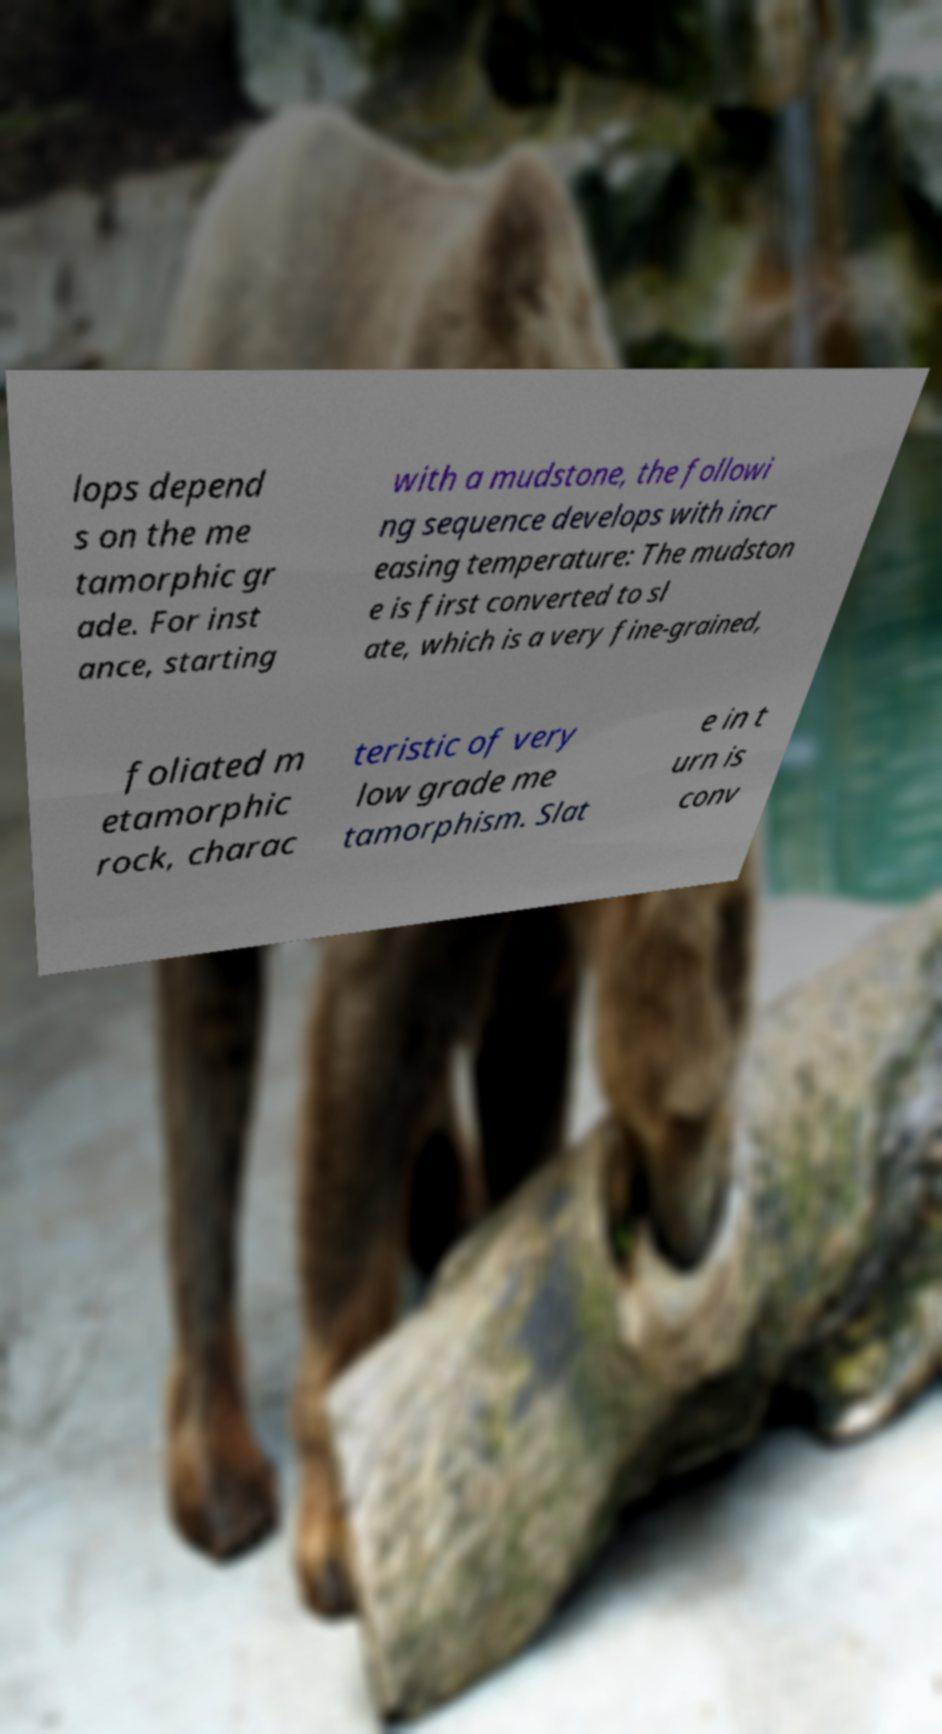Could you extract and type out the text from this image? lops depend s on the me tamorphic gr ade. For inst ance, starting with a mudstone, the followi ng sequence develops with incr easing temperature: The mudston e is first converted to sl ate, which is a very fine-grained, foliated m etamorphic rock, charac teristic of very low grade me tamorphism. Slat e in t urn is conv 